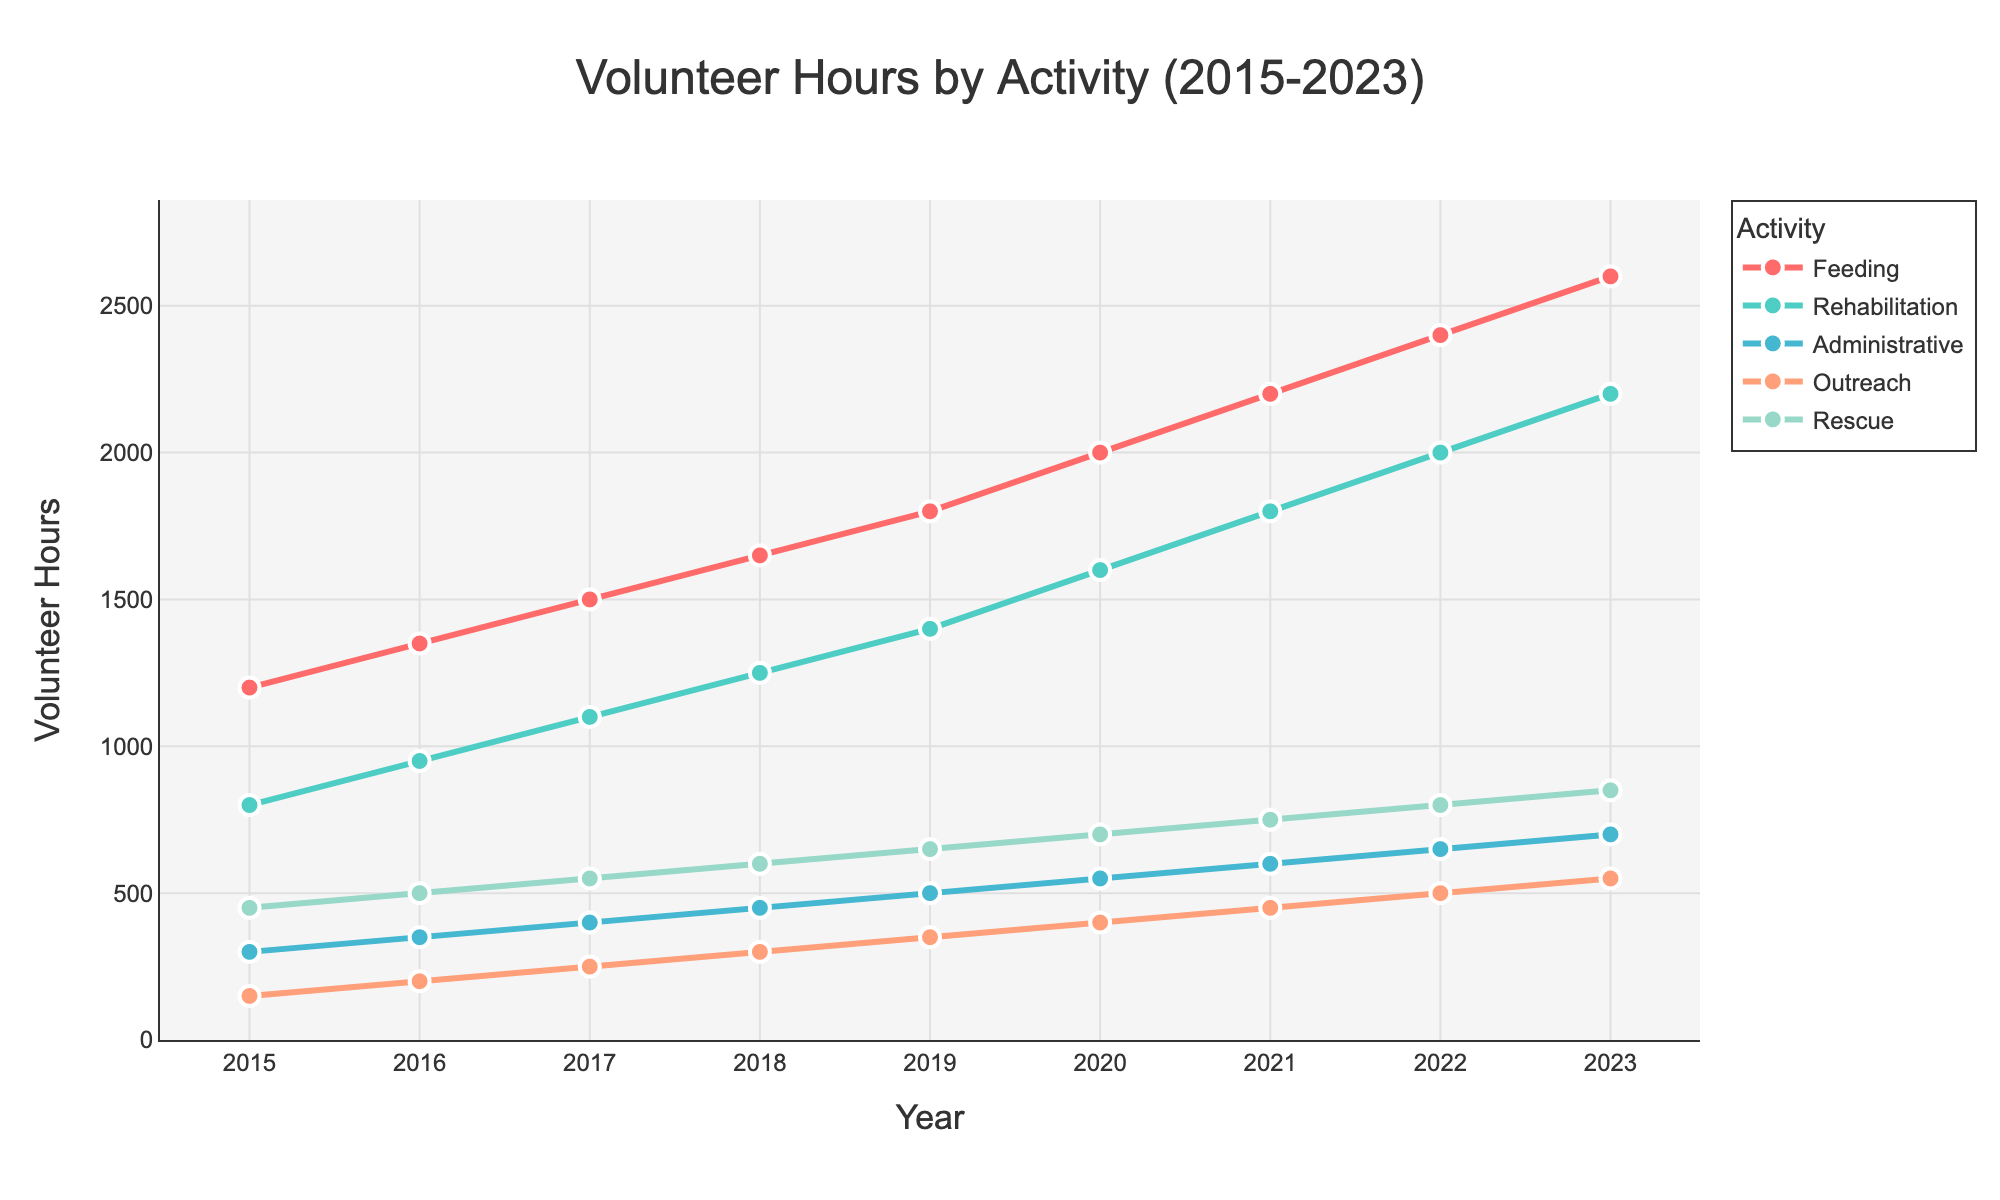what activity saw the greatest increase in volunteer hours from 2015 to 2023? To find out which activity saw the greatest increase, calculate the difference in volunteer hours between 2023 and 2015 for each activity. Feeding: 2600 - 1200 = 1400, Rehabilitation: 2200 - 800 = 1400, Administrative: 700 - 300 = 400, Outreach: 550 - 150 = 400, Rescue: 850 - 450 = 400. Both Feeding and Rehabilitation saw an increase of 1400 hours, the largest increase.
Answer: Feeding and Rehabilitation Which year had the highest overall volunteer hours contributed? To determine this, you need to sum the volunteer hours for each activity for each year and compare. Summing up the values for each activity in each year from the figure, 2023 (2600 + 2200 + 700 + 550 + 850) = 6900 hours, which is the highest value observed.
Answer: 2023 How many volunteer hours were contributed to Administrative activities in 2017 compared to 2021? Compare the Administrative hours for the years 2017 and 2021 directly from the plot: In 2017, Administrative hours = 400, and in 2021 = 600. The difference between the years is 600 - 400 = 200 hours.
Answer: 200 What's the average number of volunteer hours contributed to Outreach activities from 2015 to 2023? Calculate the average by summing the volunteer hours for Outreach activities over the years (150 + 200 + 250 + 300 + 350 + 400 + 450 + 500 + 550) = 3150, then divide by the number of years (9). 3150 / 9 = 350.
Answer: 350 How does the trend in Rescue volunteer hours compare to the trend in Rehabilitation volunteer hours from 2015 to 2023? Both trends can be compared by visually analyzing their slopes in the plot. Rescue and Rehabilitation hours both show a consistent and steady increase over the years, but the absolute increase in Rehabilitation hours (from 800 in 2015 to 2200 in 2023) is much higher compared to Rescue hours (from 450 to 850).
Answer: Rehabilitation increased more Which activity had the least number of volunteer hours in 2019? Observe the values corresponding to 2019 in the plot for all activities. Administrative had 500 hours, which is the least compared to others in this year.
Answer: Administrative What's the overall trend for Feeding volunteer hours from 2015 to 2023? Examine the Feeding line (typically represented in red) on the plot. The number of hours shows a consistent upward trend from 1200 hours in 2015 to 2600 hours in 2023. Hence, there's a clear increase each year.
Answer: Increasing Which two activities had nearly the same amount of volunteer hours contributed in 2020? Look for the lines that are close to each other in 2020 in the plot. Administrative and Outreach have similar values, with Administrative at 550 hours and Outreach at 400 hours. They are the closest compared to other pairs.
Answer: Administrative and Outreach What is the linear progression rate (average yearly increase) for Rehabilitation volunteer hours from 2015 to 2023? Calculate the total increase in hours for Rehabilitation (2200 - 800 = 1400). Then divide by the number of years (2023 - 2015 = 8) to get the average yearly increase. 1400 / 8 = 175 hours per year.
Answer: 175 Which year saw the smallest increase in Feeding volunteer hours compared to the previous year? Checking year-over-year differences, the smallest increase is between 2018 (1650) and 2017 (1500), which is 1650 - 1500 = 150 hours.
Answer: 2018 